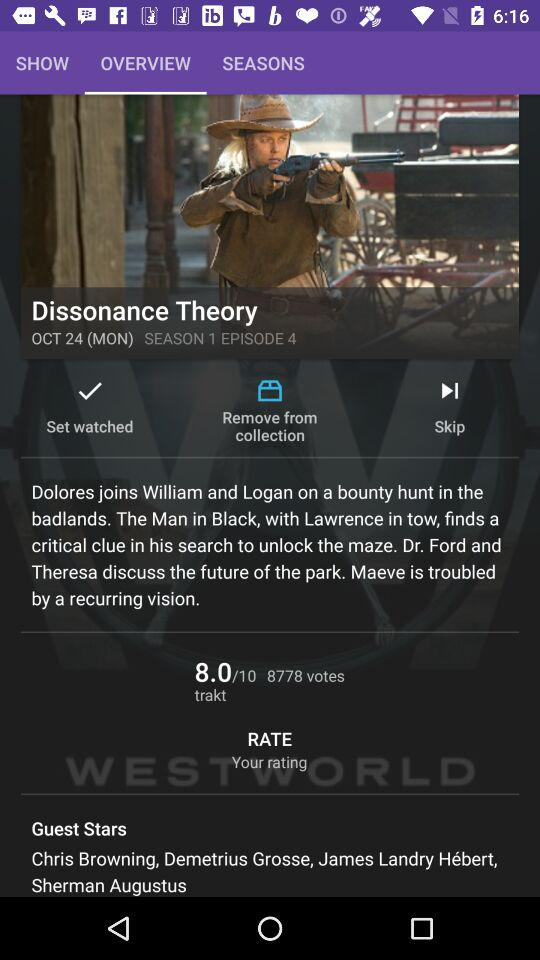What are the names of the guest stars? The names of the guest stars are Chris Browning, Demetrius Grosse, James Landry Hébert and Sherman Augustus. 